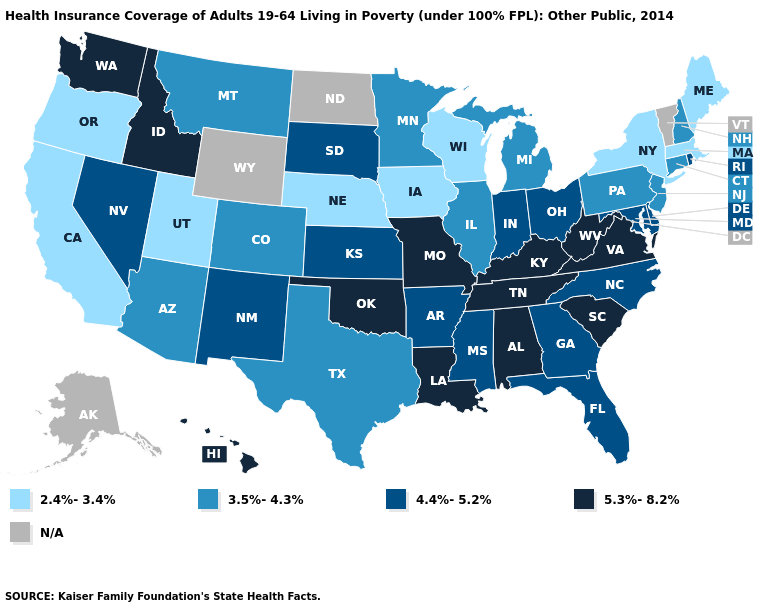What is the value of Alabama?
Short answer required. 5.3%-8.2%. What is the value of Pennsylvania?
Be succinct. 3.5%-4.3%. What is the value of Michigan?
Short answer required. 3.5%-4.3%. Does the map have missing data?
Keep it brief. Yes. Is the legend a continuous bar?
Quick response, please. No. Which states hav the highest value in the MidWest?
Keep it brief. Missouri. Which states hav the highest value in the MidWest?
Concise answer only. Missouri. What is the highest value in the Northeast ?
Give a very brief answer. 4.4%-5.2%. Name the states that have a value in the range 4.4%-5.2%?
Quick response, please. Arkansas, Delaware, Florida, Georgia, Indiana, Kansas, Maryland, Mississippi, Nevada, New Mexico, North Carolina, Ohio, Rhode Island, South Dakota. Among the states that border Missouri , does Tennessee have the lowest value?
Write a very short answer. No. What is the lowest value in the South?
Be succinct. 3.5%-4.3%. Name the states that have a value in the range 5.3%-8.2%?
Keep it brief. Alabama, Hawaii, Idaho, Kentucky, Louisiana, Missouri, Oklahoma, South Carolina, Tennessee, Virginia, Washington, West Virginia. What is the value of Kentucky?
Quick response, please. 5.3%-8.2%. Name the states that have a value in the range 2.4%-3.4%?
Concise answer only. California, Iowa, Maine, Massachusetts, Nebraska, New York, Oregon, Utah, Wisconsin. 